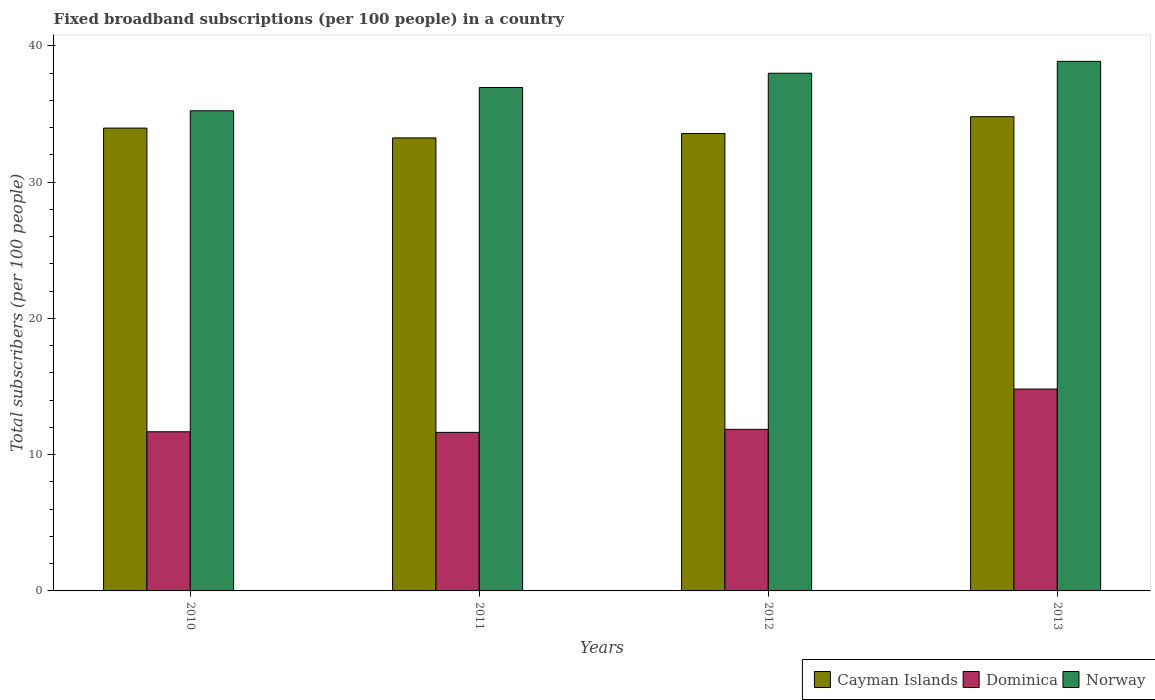How many different coloured bars are there?
Your answer should be compact. 3. How many groups of bars are there?
Your answer should be compact. 4. How many bars are there on the 2nd tick from the left?
Keep it short and to the point. 3. In how many cases, is the number of bars for a given year not equal to the number of legend labels?
Your response must be concise. 0. What is the number of broadband subscriptions in Norway in 2011?
Provide a short and direct response. 36.94. Across all years, what is the maximum number of broadband subscriptions in Dominica?
Give a very brief answer. 14.81. Across all years, what is the minimum number of broadband subscriptions in Norway?
Give a very brief answer. 35.23. In which year was the number of broadband subscriptions in Dominica minimum?
Provide a succinct answer. 2011. What is the total number of broadband subscriptions in Cayman Islands in the graph?
Give a very brief answer. 135.57. What is the difference between the number of broadband subscriptions in Dominica in 2010 and that in 2012?
Offer a terse response. -0.18. What is the difference between the number of broadband subscriptions in Cayman Islands in 2012 and the number of broadband subscriptions in Norway in 2013?
Offer a terse response. -5.29. What is the average number of broadband subscriptions in Dominica per year?
Keep it short and to the point. 12.5. In the year 2012, what is the difference between the number of broadband subscriptions in Cayman Islands and number of broadband subscriptions in Norway?
Your answer should be compact. -4.42. What is the ratio of the number of broadband subscriptions in Norway in 2011 to that in 2013?
Provide a succinct answer. 0.95. Is the number of broadband subscriptions in Norway in 2011 less than that in 2013?
Your answer should be compact. Yes. Is the difference between the number of broadband subscriptions in Cayman Islands in 2011 and 2012 greater than the difference between the number of broadband subscriptions in Norway in 2011 and 2012?
Your answer should be compact. Yes. What is the difference between the highest and the second highest number of broadband subscriptions in Dominica?
Ensure brevity in your answer.  2.96. What is the difference between the highest and the lowest number of broadband subscriptions in Cayman Islands?
Your answer should be compact. 1.56. In how many years, is the number of broadband subscriptions in Dominica greater than the average number of broadband subscriptions in Dominica taken over all years?
Offer a very short reply. 1. What does the 1st bar from the left in 2013 represents?
Your answer should be compact. Cayman Islands. What does the 2nd bar from the right in 2010 represents?
Keep it short and to the point. Dominica. Is it the case that in every year, the sum of the number of broadband subscriptions in Norway and number of broadband subscriptions in Dominica is greater than the number of broadband subscriptions in Cayman Islands?
Provide a succinct answer. Yes. How many bars are there?
Provide a short and direct response. 12. Are the values on the major ticks of Y-axis written in scientific E-notation?
Your answer should be very brief. No. Does the graph contain any zero values?
Make the answer very short. No. Where does the legend appear in the graph?
Your response must be concise. Bottom right. What is the title of the graph?
Offer a very short reply. Fixed broadband subscriptions (per 100 people) in a country. What is the label or title of the Y-axis?
Ensure brevity in your answer.  Total subscribers (per 100 people). What is the Total subscribers (per 100 people) in Cayman Islands in 2010?
Your answer should be compact. 33.96. What is the Total subscribers (per 100 people) in Dominica in 2010?
Offer a very short reply. 11.68. What is the Total subscribers (per 100 people) in Norway in 2010?
Your answer should be compact. 35.23. What is the Total subscribers (per 100 people) in Cayman Islands in 2011?
Keep it short and to the point. 33.24. What is the Total subscribers (per 100 people) in Dominica in 2011?
Your response must be concise. 11.63. What is the Total subscribers (per 100 people) of Norway in 2011?
Give a very brief answer. 36.94. What is the Total subscribers (per 100 people) in Cayman Islands in 2012?
Make the answer very short. 33.57. What is the Total subscribers (per 100 people) in Dominica in 2012?
Keep it short and to the point. 11.86. What is the Total subscribers (per 100 people) of Norway in 2012?
Offer a terse response. 37.99. What is the Total subscribers (per 100 people) of Cayman Islands in 2013?
Make the answer very short. 34.8. What is the Total subscribers (per 100 people) in Dominica in 2013?
Make the answer very short. 14.81. What is the Total subscribers (per 100 people) in Norway in 2013?
Keep it short and to the point. 38.86. Across all years, what is the maximum Total subscribers (per 100 people) of Cayman Islands?
Provide a short and direct response. 34.8. Across all years, what is the maximum Total subscribers (per 100 people) of Dominica?
Offer a terse response. 14.81. Across all years, what is the maximum Total subscribers (per 100 people) of Norway?
Your response must be concise. 38.86. Across all years, what is the minimum Total subscribers (per 100 people) in Cayman Islands?
Provide a short and direct response. 33.24. Across all years, what is the minimum Total subscribers (per 100 people) of Dominica?
Your response must be concise. 11.63. Across all years, what is the minimum Total subscribers (per 100 people) in Norway?
Give a very brief answer. 35.23. What is the total Total subscribers (per 100 people) in Cayman Islands in the graph?
Your answer should be compact. 135.57. What is the total Total subscribers (per 100 people) in Dominica in the graph?
Keep it short and to the point. 49.98. What is the total Total subscribers (per 100 people) of Norway in the graph?
Your answer should be compact. 149.03. What is the difference between the Total subscribers (per 100 people) in Cayman Islands in 2010 and that in 2011?
Your answer should be compact. 0.72. What is the difference between the Total subscribers (per 100 people) of Dominica in 2010 and that in 2011?
Offer a very short reply. 0.04. What is the difference between the Total subscribers (per 100 people) in Norway in 2010 and that in 2011?
Offer a terse response. -1.71. What is the difference between the Total subscribers (per 100 people) in Cayman Islands in 2010 and that in 2012?
Your answer should be compact. 0.39. What is the difference between the Total subscribers (per 100 people) in Dominica in 2010 and that in 2012?
Offer a very short reply. -0.18. What is the difference between the Total subscribers (per 100 people) in Norway in 2010 and that in 2012?
Your response must be concise. -2.75. What is the difference between the Total subscribers (per 100 people) of Cayman Islands in 2010 and that in 2013?
Make the answer very short. -0.84. What is the difference between the Total subscribers (per 100 people) of Dominica in 2010 and that in 2013?
Keep it short and to the point. -3.14. What is the difference between the Total subscribers (per 100 people) of Norway in 2010 and that in 2013?
Your answer should be compact. -3.63. What is the difference between the Total subscribers (per 100 people) of Cayman Islands in 2011 and that in 2012?
Make the answer very short. -0.32. What is the difference between the Total subscribers (per 100 people) in Dominica in 2011 and that in 2012?
Ensure brevity in your answer.  -0.22. What is the difference between the Total subscribers (per 100 people) of Norway in 2011 and that in 2012?
Your answer should be very brief. -1.04. What is the difference between the Total subscribers (per 100 people) in Cayman Islands in 2011 and that in 2013?
Keep it short and to the point. -1.56. What is the difference between the Total subscribers (per 100 people) in Dominica in 2011 and that in 2013?
Offer a very short reply. -3.18. What is the difference between the Total subscribers (per 100 people) in Norway in 2011 and that in 2013?
Your response must be concise. -1.92. What is the difference between the Total subscribers (per 100 people) of Cayman Islands in 2012 and that in 2013?
Your response must be concise. -1.23. What is the difference between the Total subscribers (per 100 people) in Dominica in 2012 and that in 2013?
Your response must be concise. -2.96. What is the difference between the Total subscribers (per 100 people) in Norway in 2012 and that in 2013?
Give a very brief answer. -0.87. What is the difference between the Total subscribers (per 100 people) in Cayman Islands in 2010 and the Total subscribers (per 100 people) in Dominica in 2011?
Make the answer very short. 22.33. What is the difference between the Total subscribers (per 100 people) of Cayman Islands in 2010 and the Total subscribers (per 100 people) of Norway in 2011?
Make the answer very short. -2.98. What is the difference between the Total subscribers (per 100 people) in Dominica in 2010 and the Total subscribers (per 100 people) in Norway in 2011?
Provide a short and direct response. -25.27. What is the difference between the Total subscribers (per 100 people) in Cayman Islands in 2010 and the Total subscribers (per 100 people) in Dominica in 2012?
Provide a succinct answer. 22.1. What is the difference between the Total subscribers (per 100 people) of Cayman Islands in 2010 and the Total subscribers (per 100 people) of Norway in 2012?
Provide a succinct answer. -4.03. What is the difference between the Total subscribers (per 100 people) of Dominica in 2010 and the Total subscribers (per 100 people) of Norway in 2012?
Keep it short and to the point. -26.31. What is the difference between the Total subscribers (per 100 people) of Cayman Islands in 2010 and the Total subscribers (per 100 people) of Dominica in 2013?
Provide a succinct answer. 19.15. What is the difference between the Total subscribers (per 100 people) of Cayman Islands in 2010 and the Total subscribers (per 100 people) of Norway in 2013?
Your answer should be very brief. -4.9. What is the difference between the Total subscribers (per 100 people) of Dominica in 2010 and the Total subscribers (per 100 people) of Norway in 2013?
Keep it short and to the point. -27.18. What is the difference between the Total subscribers (per 100 people) in Cayman Islands in 2011 and the Total subscribers (per 100 people) in Dominica in 2012?
Your response must be concise. 21.39. What is the difference between the Total subscribers (per 100 people) of Cayman Islands in 2011 and the Total subscribers (per 100 people) of Norway in 2012?
Your response must be concise. -4.75. What is the difference between the Total subscribers (per 100 people) of Dominica in 2011 and the Total subscribers (per 100 people) of Norway in 2012?
Provide a succinct answer. -26.35. What is the difference between the Total subscribers (per 100 people) in Cayman Islands in 2011 and the Total subscribers (per 100 people) in Dominica in 2013?
Your answer should be compact. 18.43. What is the difference between the Total subscribers (per 100 people) of Cayman Islands in 2011 and the Total subscribers (per 100 people) of Norway in 2013?
Ensure brevity in your answer.  -5.62. What is the difference between the Total subscribers (per 100 people) in Dominica in 2011 and the Total subscribers (per 100 people) in Norway in 2013?
Your response must be concise. -27.23. What is the difference between the Total subscribers (per 100 people) in Cayman Islands in 2012 and the Total subscribers (per 100 people) in Dominica in 2013?
Ensure brevity in your answer.  18.75. What is the difference between the Total subscribers (per 100 people) in Cayman Islands in 2012 and the Total subscribers (per 100 people) in Norway in 2013?
Make the answer very short. -5.29. What is the difference between the Total subscribers (per 100 people) in Dominica in 2012 and the Total subscribers (per 100 people) in Norway in 2013?
Make the answer very short. -27. What is the average Total subscribers (per 100 people) in Cayman Islands per year?
Your answer should be very brief. 33.89. What is the average Total subscribers (per 100 people) of Dominica per year?
Give a very brief answer. 12.5. What is the average Total subscribers (per 100 people) of Norway per year?
Ensure brevity in your answer.  37.26. In the year 2010, what is the difference between the Total subscribers (per 100 people) in Cayman Islands and Total subscribers (per 100 people) in Dominica?
Make the answer very short. 22.28. In the year 2010, what is the difference between the Total subscribers (per 100 people) of Cayman Islands and Total subscribers (per 100 people) of Norway?
Make the answer very short. -1.27. In the year 2010, what is the difference between the Total subscribers (per 100 people) in Dominica and Total subscribers (per 100 people) in Norway?
Offer a very short reply. -23.56. In the year 2011, what is the difference between the Total subscribers (per 100 people) of Cayman Islands and Total subscribers (per 100 people) of Dominica?
Provide a succinct answer. 21.61. In the year 2011, what is the difference between the Total subscribers (per 100 people) in Cayman Islands and Total subscribers (per 100 people) in Norway?
Provide a succinct answer. -3.7. In the year 2011, what is the difference between the Total subscribers (per 100 people) of Dominica and Total subscribers (per 100 people) of Norway?
Offer a very short reply. -25.31. In the year 2012, what is the difference between the Total subscribers (per 100 people) in Cayman Islands and Total subscribers (per 100 people) in Dominica?
Your answer should be very brief. 21.71. In the year 2012, what is the difference between the Total subscribers (per 100 people) in Cayman Islands and Total subscribers (per 100 people) in Norway?
Provide a succinct answer. -4.42. In the year 2012, what is the difference between the Total subscribers (per 100 people) of Dominica and Total subscribers (per 100 people) of Norway?
Your answer should be compact. -26.13. In the year 2013, what is the difference between the Total subscribers (per 100 people) in Cayman Islands and Total subscribers (per 100 people) in Dominica?
Provide a succinct answer. 19.98. In the year 2013, what is the difference between the Total subscribers (per 100 people) of Cayman Islands and Total subscribers (per 100 people) of Norway?
Your answer should be compact. -4.06. In the year 2013, what is the difference between the Total subscribers (per 100 people) in Dominica and Total subscribers (per 100 people) in Norway?
Your answer should be compact. -24.05. What is the ratio of the Total subscribers (per 100 people) of Cayman Islands in 2010 to that in 2011?
Ensure brevity in your answer.  1.02. What is the ratio of the Total subscribers (per 100 people) of Dominica in 2010 to that in 2011?
Provide a succinct answer. 1. What is the ratio of the Total subscribers (per 100 people) in Norway in 2010 to that in 2011?
Keep it short and to the point. 0.95. What is the ratio of the Total subscribers (per 100 people) in Cayman Islands in 2010 to that in 2012?
Provide a succinct answer. 1.01. What is the ratio of the Total subscribers (per 100 people) of Dominica in 2010 to that in 2012?
Your answer should be very brief. 0.98. What is the ratio of the Total subscribers (per 100 people) in Norway in 2010 to that in 2012?
Your response must be concise. 0.93. What is the ratio of the Total subscribers (per 100 people) in Cayman Islands in 2010 to that in 2013?
Give a very brief answer. 0.98. What is the ratio of the Total subscribers (per 100 people) of Dominica in 2010 to that in 2013?
Make the answer very short. 0.79. What is the ratio of the Total subscribers (per 100 people) in Norway in 2010 to that in 2013?
Provide a short and direct response. 0.91. What is the ratio of the Total subscribers (per 100 people) of Cayman Islands in 2011 to that in 2012?
Your answer should be compact. 0.99. What is the ratio of the Total subscribers (per 100 people) of Dominica in 2011 to that in 2012?
Make the answer very short. 0.98. What is the ratio of the Total subscribers (per 100 people) of Norway in 2011 to that in 2012?
Keep it short and to the point. 0.97. What is the ratio of the Total subscribers (per 100 people) of Cayman Islands in 2011 to that in 2013?
Keep it short and to the point. 0.96. What is the ratio of the Total subscribers (per 100 people) in Dominica in 2011 to that in 2013?
Ensure brevity in your answer.  0.79. What is the ratio of the Total subscribers (per 100 people) in Norway in 2011 to that in 2013?
Ensure brevity in your answer.  0.95. What is the ratio of the Total subscribers (per 100 people) in Cayman Islands in 2012 to that in 2013?
Keep it short and to the point. 0.96. What is the ratio of the Total subscribers (per 100 people) in Dominica in 2012 to that in 2013?
Your answer should be very brief. 0.8. What is the ratio of the Total subscribers (per 100 people) of Norway in 2012 to that in 2013?
Keep it short and to the point. 0.98. What is the difference between the highest and the second highest Total subscribers (per 100 people) of Cayman Islands?
Give a very brief answer. 0.84. What is the difference between the highest and the second highest Total subscribers (per 100 people) in Dominica?
Provide a short and direct response. 2.96. What is the difference between the highest and the second highest Total subscribers (per 100 people) of Norway?
Ensure brevity in your answer.  0.87. What is the difference between the highest and the lowest Total subscribers (per 100 people) of Cayman Islands?
Provide a succinct answer. 1.56. What is the difference between the highest and the lowest Total subscribers (per 100 people) in Dominica?
Provide a short and direct response. 3.18. What is the difference between the highest and the lowest Total subscribers (per 100 people) of Norway?
Offer a very short reply. 3.63. 